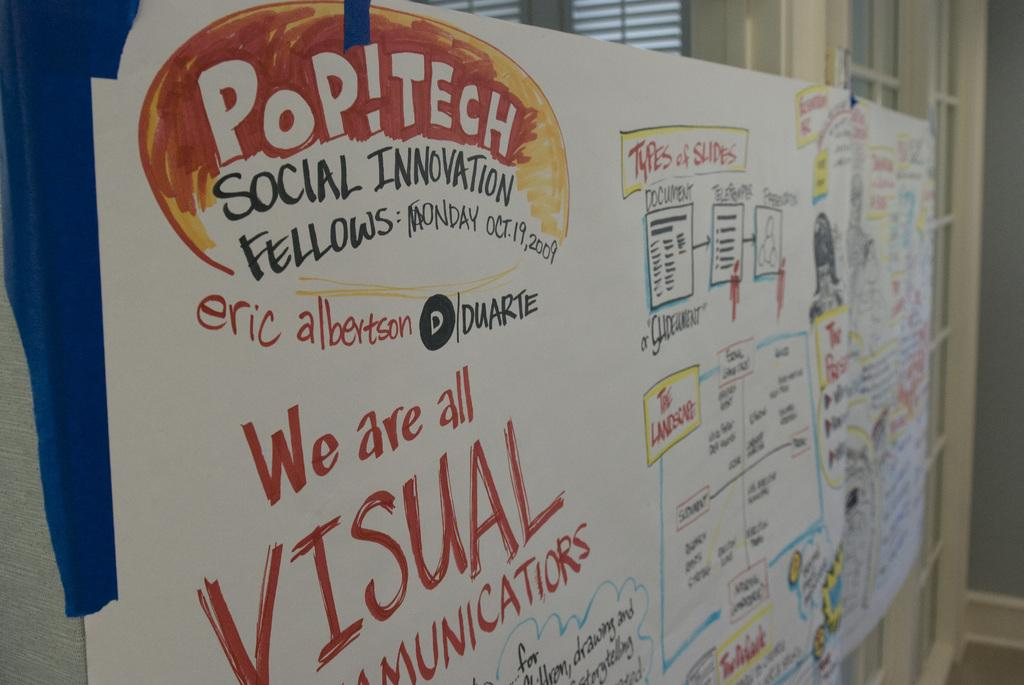What is the main object in the image? There is a whiteboard in the image. What can be seen on the whiteboard? The whiteboard has text on it. What architectural features are visible in the background of the image? There are doors and blinds in the background of the image. What type of tail can be seen on the whiteboard in the image? There is no tail present on the whiteboard or in the image. 